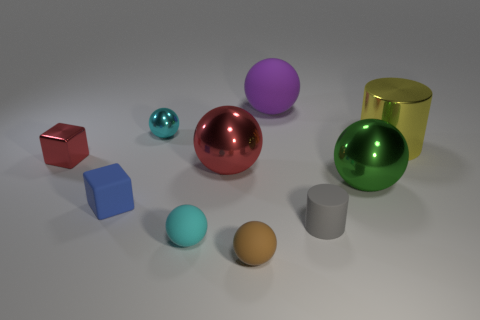There is another tiny metallic object that is the same shape as the green shiny object; what color is it? cyan 